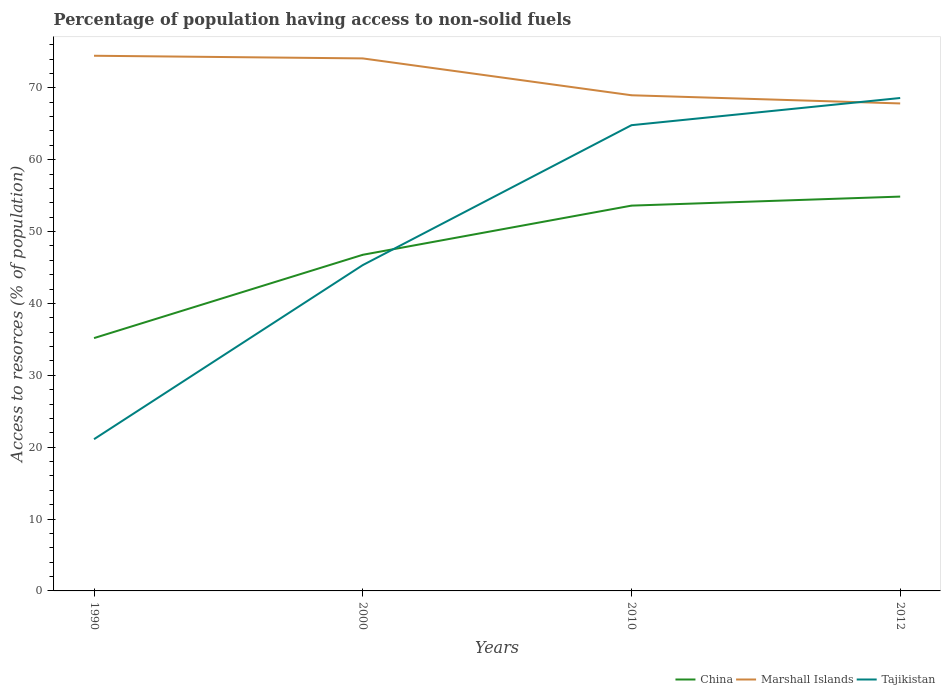Is the number of lines equal to the number of legend labels?
Offer a very short reply. Yes. Across all years, what is the maximum percentage of population having access to non-solid fuels in Marshall Islands?
Give a very brief answer. 67.83. In which year was the percentage of population having access to non-solid fuels in Tajikistan maximum?
Keep it short and to the point. 1990. What is the total percentage of population having access to non-solid fuels in China in the graph?
Your answer should be compact. -1.26. What is the difference between the highest and the second highest percentage of population having access to non-solid fuels in Tajikistan?
Your answer should be very brief. 47.47. How many years are there in the graph?
Provide a succinct answer. 4. Are the values on the major ticks of Y-axis written in scientific E-notation?
Keep it short and to the point. No. Where does the legend appear in the graph?
Keep it short and to the point. Bottom right. What is the title of the graph?
Offer a very short reply. Percentage of population having access to non-solid fuels. Does "Barbados" appear as one of the legend labels in the graph?
Your answer should be compact. No. What is the label or title of the Y-axis?
Your answer should be compact. Access to resorces (% of population). What is the Access to resorces (% of population) of China in 1990?
Offer a terse response. 35.18. What is the Access to resorces (% of population) of Marshall Islands in 1990?
Make the answer very short. 74.47. What is the Access to resorces (% of population) of Tajikistan in 1990?
Keep it short and to the point. 21.11. What is the Access to resorces (% of population) in China in 2000?
Make the answer very short. 46.77. What is the Access to resorces (% of population) of Marshall Islands in 2000?
Ensure brevity in your answer.  74.09. What is the Access to resorces (% of population) of Tajikistan in 2000?
Give a very brief answer. 45.34. What is the Access to resorces (% of population) in China in 2010?
Offer a very short reply. 53.61. What is the Access to resorces (% of population) in Marshall Islands in 2010?
Make the answer very short. 68.97. What is the Access to resorces (% of population) of Tajikistan in 2010?
Your answer should be compact. 64.8. What is the Access to resorces (% of population) in China in 2012?
Offer a very short reply. 54.87. What is the Access to resorces (% of population) of Marshall Islands in 2012?
Ensure brevity in your answer.  67.83. What is the Access to resorces (% of population) in Tajikistan in 2012?
Offer a very short reply. 68.59. Across all years, what is the maximum Access to resorces (% of population) in China?
Your response must be concise. 54.87. Across all years, what is the maximum Access to resorces (% of population) of Marshall Islands?
Keep it short and to the point. 74.47. Across all years, what is the maximum Access to resorces (% of population) in Tajikistan?
Offer a terse response. 68.59. Across all years, what is the minimum Access to resorces (% of population) of China?
Offer a very short reply. 35.18. Across all years, what is the minimum Access to resorces (% of population) in Marshall Islands?
Your answer should be very brief. 67.83. Across all years, what is the minimum Access to resorces (% of population) of Tajikistan?
Keep it short and to the point. 21.11. What is the total Access to resorces (% of population) in China in the graph?
Give a very brief answer. 190.42. What is the total Access to resorces (% of population) in Marshall Islands in the graph?
Make the answer very short. 285.36. What is the total Access to resorces (% of population) in Tajikistan in the graph?
Make the answer very short. 199.84. What is the difference between the Access to resorces (% of population) in China in 1990 and that in 2000?
Provide a succinct answer. -11.59. What is the difference between the Access to resorces (% of population) in Marshall Islands in 1990 and that in 2000?
Keep it short and to the point. 0.37. What is the difference between the Access to resorces (% of population) of Tajikistan in 1990 and that in 2000?
Offer a terse response. -24.22. What is the difference between the Access to resorces (% of population) of China in 1990 and that in 2010?
Make the answer very short. -18.43. What is the difference between the Access to resorces (% of population) in Marshall Islands in 1990 and that in 2010?
Provide a succinct answer. 5.5. What is the difference between the Access to resorces (% of population) of Tajikistan in 1990 and that in 2010?
Give a very brief answer. -43.69. What is the difference between the Access to resorces (% of population) in China in 1990 and that in 2012?
Offer a very short reply. -19.69. What is the difference between the Access to resorces (% of population) of Marshall Islands in 1990 and that in 2012?
Ensure brevity in your answer.  6.64. What is the difference between the Access to resorces (% of population) in Tajikistan in 1990 and that in 2012?
Offer a very short reply. -47.47. What is the difference between the Access to resorces (% of population) in China in 2000 and that in 2010?
Keep it short and to the point. -6.84. What is the difference between the Access to resorces (% of population) of Marshall Islands in 2000 and that in 2010?
Give a very brief answer. 5.13. What is the difference between the Access to resorces (% of population) of Tajikistan in 2000 and that in 2010?
Your answer should be very brief. -19.47. What is the difference between the Access to resorces (% of population) in China in 2000 and that in 2012?
Offer a very short reply. -8.1. What is the difference between the Access to resorces (% of population) in Marshall Islands in 2000 and that in 2012?
Your answer should be compact. 6.27. What is the difference between the Access to resorces (% of population) of Tajikistan in 2000 and that in 2012?
Your response must be concise. -23.25. What is the difference between the Access to resorces (% of population) in China in 2010 and that in 2012?
Your answer should be very brief. -1.26. What is the difference between the Access to resorces (% of population) of Marshall Islands in 2010 and that in 2012?
Offer a terse response. 1.14. What is the difference between the Access to resorces (% of population) of Tajikistan in 2010 and that in 2012?
Your answer should be very brief. -3.78. What is the difference between the Access to resorces (% of population) of China in 1990 and the Access to resorces (% of population) of Marshall Islands in 2000?
Your answer should be very brief. -38.92. What is the difference between the Access to resorces (% of population) in China in 1990 and the Access to resorces (% of population) in Tajikistan in 2000?
Give a very brief answer. -10.16. What is the difference between the Access to resorces (% of population) in Marshall Islands in 1990 and the Access to resorces (% of population) in Tajikistan in 2000?
Your response must be concise. 29.13. What is the difference between the Access to resorces (% of population) in China in 1990 and the Access to resorces (% of population) in Marshall Islands in 2010?
Provide a short and direct response. -33.79. What is the difference between the Access to resorces (% of population) in China in 1990 and the Access to resorces (% of population) in Tajikistan in 2010?
Your answer should be very brief. -29.62. What is the difference between the Access to resorces (% of population) of Marshall Islands in 1990 and the Access to resorces (% of population) of Tajikistan in 2010?
Your answer should be very brief. 9.66. What is the difference between the Access to resorces (% of population) of China in 1990 and the Access to resorces (% of population) of Marshall Islands in 2012?
Provide a short and direct response. -32.65. What is the difference between the Access to resorces (% of population) of China in 1990 and the Access to resorces (% of population) of Tajikistan in 2012?
Ensure brevity in your answer.  -33.41. What is the difference between the Access to resorces (% of population) of Marshall Islands in 1990 and the Access to resorces (% of population) of Tajikistan in 2012?
Offer a terse response. 5.88. What is the difference between the Access to resorces (% of population) in China in 2000 and the Access to resorces (% of population) in Marshall Islands in 2010?
Ensure brevity in your answer.  -22.2. What is the difference between the Access to resorces (% of population) in China in 2000 and the Access to resorces (% of population) in Tajikistan in 2010?
Provide a short and direct response. -18.03. What is the difference between the Access to resorces (% of population) in Marshall Islands in 2000 and the Access to resorces (% of population) in Tajikistan in 2010?
Your answer should be compact. 9.29. What is the difference between the Access to resorces (% of population) of China in 2000 and the Access to resorces (% of population) of Marshall Islands in 2012?
Provide a short and direct response. -21.06. What is the difference between the Access to resorces (% of population) in China in 2000 and the Access to resorces (% of population) in Tajikistan in 2012?
Provide a short and direct response. -21.82. What is the difference between the Access to resorces (% of population) in Marshall Islands in 2000 and the Access to resorces (% of population) in Tajikistan in 2012?
Provide a short and direct response. 5.51. What is the difference between the Access to resorces (% of population) in China in 2010 and the Access to resorces (% of population) in Marshall Islands in 2012?
Ensure brevity in your answer.  -14.22. What is the difference between the Access to resorces (% of population) in China in 2010 and the Access to resorces (% of population) in Tajikistan in 2012?
Offer a terse response. -14.98. What is the difference between the Access to resorces (% of population) in Marshall Islands in 2010 and the Access to resorces (% of population) in Tajikistan in 2012?
Make the answer very short. 0.38. What is the average Access to resorces (% of population) in China per year?
Offer a terse response. 47.61. What is the average Access to resorces (% of population) in Marshall Islands per year?
Ensure brevity in your answer.  71.34. What is the average Access to resorces (% of population) in Tajikistan per year?
Provide a short and direct response. 49.96. In the year 1990, what is the difference between the Access to resorces (% of population) of China and Access to resorces (% of population) of Marshall Islands?
Your answer should be compact. -39.29. In the year 1990, what is the difference between the Access to resorces (% of population) of China and Access to resorces (% of population) of Tajikistan?
Offer a very short reply. 14.07. In the year 1990, what is the difference between the Access to resorces (% of population) of Marshall Islands and Access to resorces (% of population) of Tajikistan?
Offer a very short reply. 53.35. In the year 2000, what is the difference between the Access to resorces (% of population) in China and Access to resorces (% of population) in Marshall Islands?
Your answer should be very brief. -27.33. In the year 2000, what is the difference between the Access to resorces (% of population) of China and Access to resorces (% of population) of Tajikistan?
Your response must be concise. 1.43. In the year 2000, what is the difference between the Access to resorces (% of population) in Marshall Islands and Access to resorces (% of population) in Tajikistan?
Give a very brief answer. 28.76. In the year 2010, what is the difference between the Access to resorces (% of population) in China and Access to resorces (% of population) in Marshall Islands?
Your response must be concise. -15.36. In the year 2010, what is the difference between the Access to resorces (% of population) of China and Access to resorces (% of population) of Tajikistan?
Provide a succinct answer. -11.19. In the year 2010, what is the difference between the Access to resorces (% of population) in Marshall Islands and Access to resorces (% of population) in Tajikistan?
Provide a succinct answer. 4.16. In the year 2012, what is the difference between the Access to resorces (% of population) in China and Access to resorces (% of population) in Marshall Islands?
Provide a short and direct response. -12.96. In the year 2012, what is the difference between the Access to resorces (% of population) of China and Access to resorces (% of population) of Tajikistan?
Offer a very short reply. -13.72. In the year 2012, what is the difference between the Access to resorces (% of population) of Marshall Islands and Access to resorces (% of population) of Tajikistan?
Provide a short and direct response. -0.76. What is the ratio of the Access to resorces (% of population) of China in 1990 to that in 2000?
Make the answer very short. 0.75. What is the ratio of the Access to resorces (% of population) of Tajikistan in 1990 to that in 2000?
Provide a succinct answer. 0.47. What is the ratio of the Access to resorces (% of population) in China in 1990 to that in 2010?
Offer a very short reply. 0.66. What is the ratio of the Access to resorces (% of population) of Marshall Islands in 1990 to that in 2010?
Keep it short and to the point. 1.08. What is the ratio of the Access to resorces (% of population) in Tajikistan in 1990 to that in 2010?
Your answer should be compact. 0.33. What is the ratio of the Access to resorces (% of population) of China in 1990 to that in 2012?
Your response must be concise. 0.64. What is the ratio of the Access to resorces (% of population) of Marshall Islands in 1990 to that in 2012?
Ensure brevity in your answer.  1.1. What is the ratio of the Access to resorces (% of population) of Tajikistan in 1990 to that in 2012?
Make the answer very short. 0.31. What is the ratio of the Access to resorces (% of population) of China in 2000 to that in 2010?
Provide a succinct answer. 0.87. What is the ratio of the Access to resorces (% of population) in Marshall Islands in 2000 to that in 2010?
Ensure brevity in your answer.  1.07. What is the ratio of the Access to resorces (% of population) of Tajikistan in 2000 to that in 2010?
Provide a short and direct response. 0.7. What is the ratio of the Access to resorces (% of population) of China in 2000 to that in 2012?
Keep it short and to the point. 0.85. What is the ratio of the Access to resorces (% of population) in Marshall Islands in 2000 to that in 2012?
Provide a short and direct response. 1.09. What is the ratio of the Access to resorces (% of population) in Tajikistan in 2000 to that in 2012?
Your response must be concise. 0.66. What is the ratio of the Access to resorces (% of population) in China in 2010 to that in 2012?
Your response must be concise. 0.98. What is the ratio of the Access to resorces (% of population) of Marshall Islands in 2010 to that in 2012?
Ensure brevity in your answer.  1.02. What is the ratio of the Access to resorces (% of population) of Tajikistan in 2010 to that in 2012?
Your response must be concise. 0.94. What is the difference between the highest and the second highest Access to resorces (% of population) in China?
Keep it short and to the point. 1.26. What is the difference between the highest and the second highest Access to resorces (% of population) in Marshall Islands?
Provide a short and direct response. 0.37. What is the difference between the highest and the second highest Access to resorces (% of population) of Tajikistan?
Provide a succinct answer. 3.78. What is the difference between the highest and the lowest Access to resorces (% of population) of China?
Give a very brief answer. 19.69. What is the difference between the highest and the lowest Access to resorces (% of population) of Marshall Islands?
Offer a terse response. 6.64. What is the difference between the highest and the lowest Access to resorces (% of population) in Tajikistan?
Ensure brevity in your answer.  47.47. 